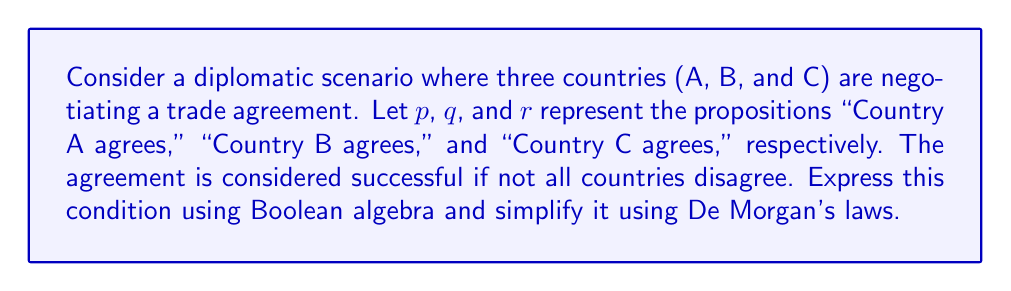What is the answer to this math problem? 1. First, let's express the condition "the agreement is successful if not all countries disagree" in Boolean algebra:

   $\lnot((\lnot p) \land (\lnot q) \land (\lnot r))$

2. Now, we can apply De Morgan's first law to simplify this expression. De Morgan's first law states:

   $\lnot(A \land B) = (\lnot A) \lor (\lnot B)$

3. Applying this law to our expression:

   $\lnot((\lnot p) \land (\lnot q) \land (\lnot r)) = (\lnot(\lnot p)) \lor (\lnot(\lnot q)) \lor (\lnot(\lnot r))$

4. Simplify the double negations:

   $(\lnot(\lnot p)) \lor (\lnot(\lnot q)) \lor (\lnot(\lnot r)) = p \lor q \lor r$

5. Therefore, the simplified expression for a successful agreement is:

   $p \lor q \lor r$

This means that the agreement is successful if at least one country agrees, which is logically equivalent to saying that not all countries disagree.
Answer: $p \lor q \lor r$ 